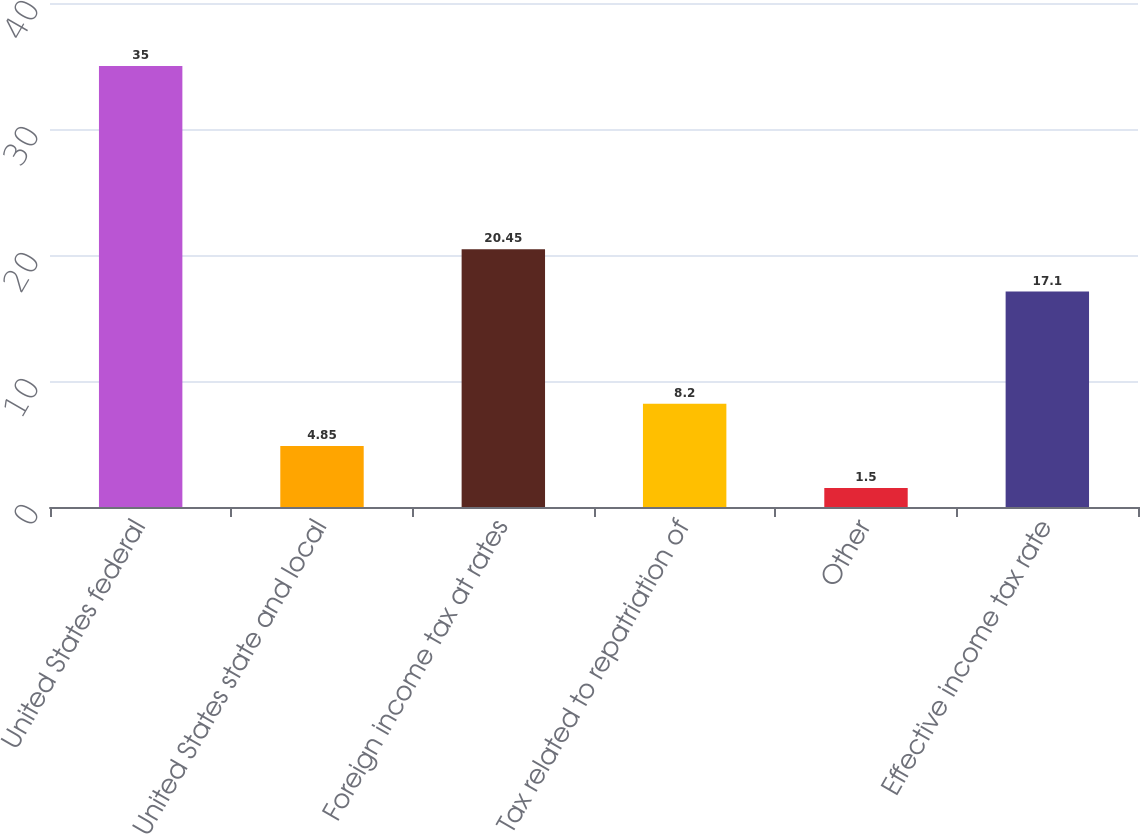Convert chart to OTSL. <chart><loc_0><loc_0><loc_500><loc_500><bar_chart><fcel>United States federal<fcel>United States state and local<fcel>Foreign income tax at rates<fcel>Tax related to repatriation of<fcel>Other<fcel>Effective income tax rate<nl><fcel>35<fcel>4.85<fcel>20.45<fcel>8.2<fcel>1.5<fcel>17.1<nl></chart> 